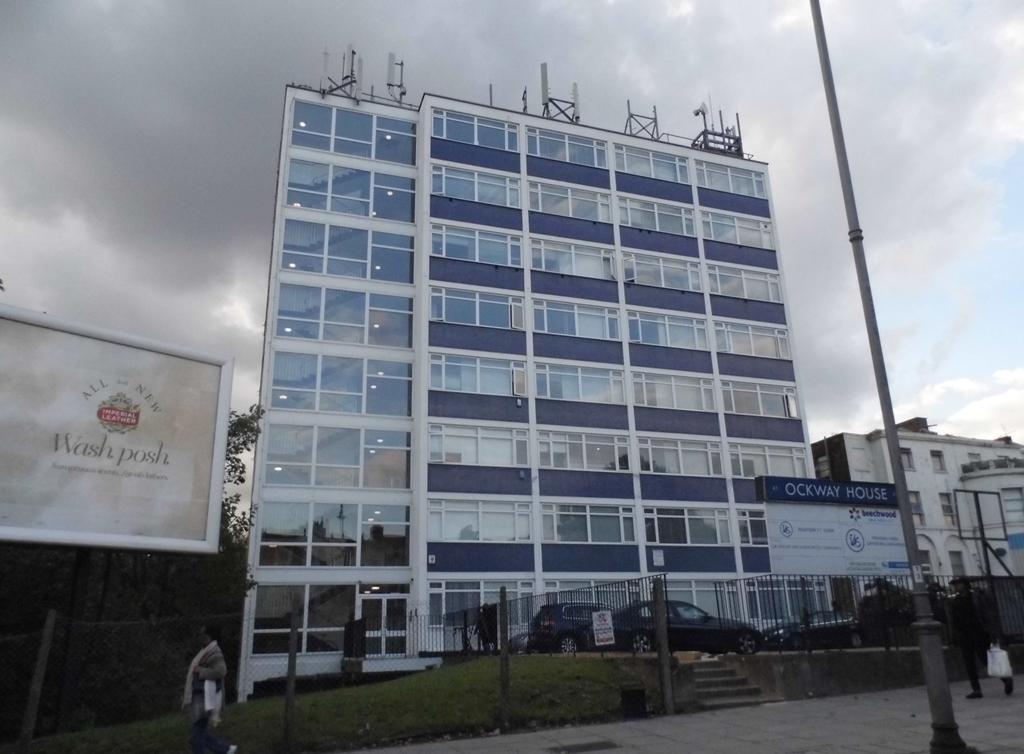In one or two sentences, can you explain what this image depicts? In this speech there is a buildings. In the bottom left corner there is a man who is walking on the street. Beside him there is a fencing. On the left we can see the advertisement board. Behind that we see the trees. In the bottom right corner there is a man who is wearing black dress and holding a plastic bag, beside him we can see the pole. In front of the building we can see black cars which is parked near to the board. At the top of the building we can see the signal towers and poles. At the top we can see sky and clouds. 